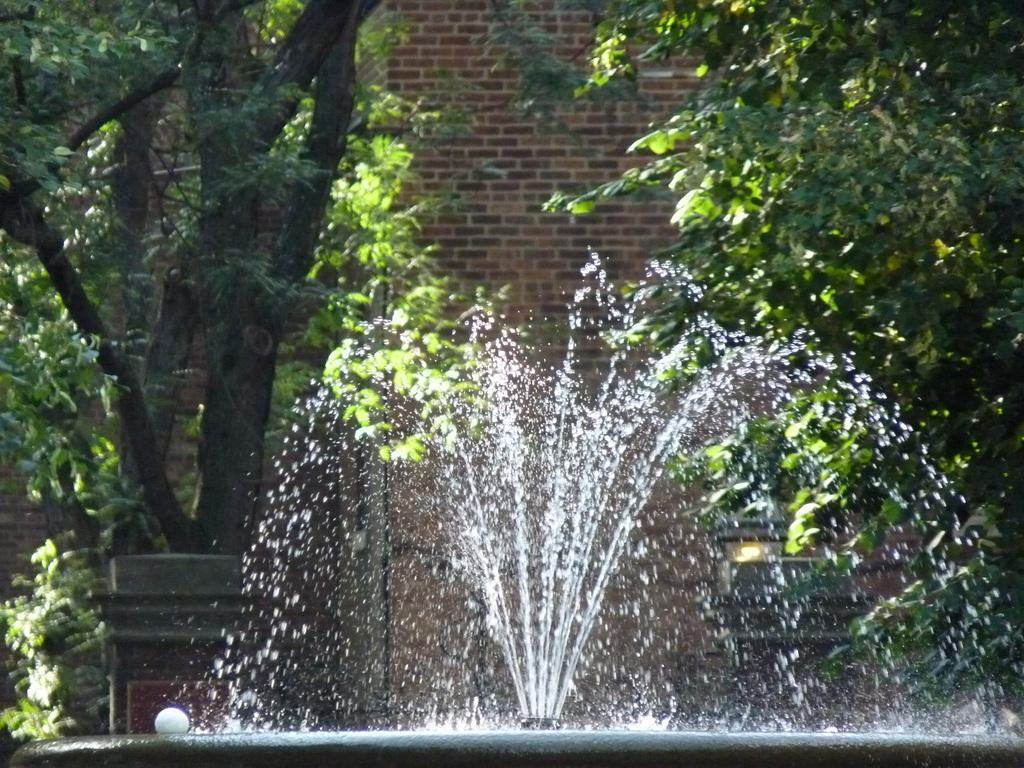What is located at the bottom of the image? There is a fountain and a ball at the bottom of the image. What can be seen in the background of the image? There are trees and a wall in the background of the image. Can you see an airplane flying above the trees in the image? There is no airplane visible in the image; it only features a fountain, a ball, trees, and a wall. What type of chain is holding the ball in the image? There is no chain present in the image. 